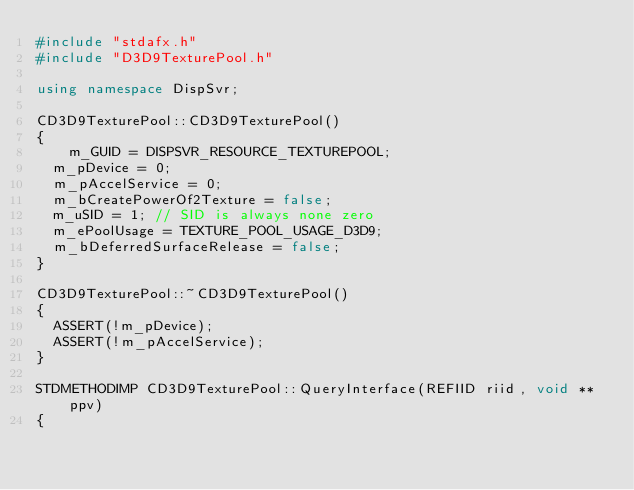Convert code to text. <code><loc_0><loc_0><loc_500><loc_500><_C++_>#include "stdafx.h"
#include "D3D9TexturePool.h"

using namespace DispSvr;

CD3D9TexturePool::CD3D9TexturePool()
{
    m_GUID = DISPSVR_RESOURCE_TEXTUREPOOL;
	m_pDevice = 0;
	m_pAccelService = 0;
	m_bCreatePowerOf2Texture = false;
	m_uSID = 1;	// SID is always none zero
	m_ePoolUsage = TEXTURE_POOL_USAGE_D3D9;
	m_bDeferredSurfaceRelease = false;
}

CD3D9TexturePool::~CD3D9TexturePool()
{
	ASSERT(!m_pDevice);
	ASSERT(!m_pAccelService);
}

STDMETHODIMP CD3D9TexturePool::QueryInterface(REFIID riid, void **ppv)
{</code> 